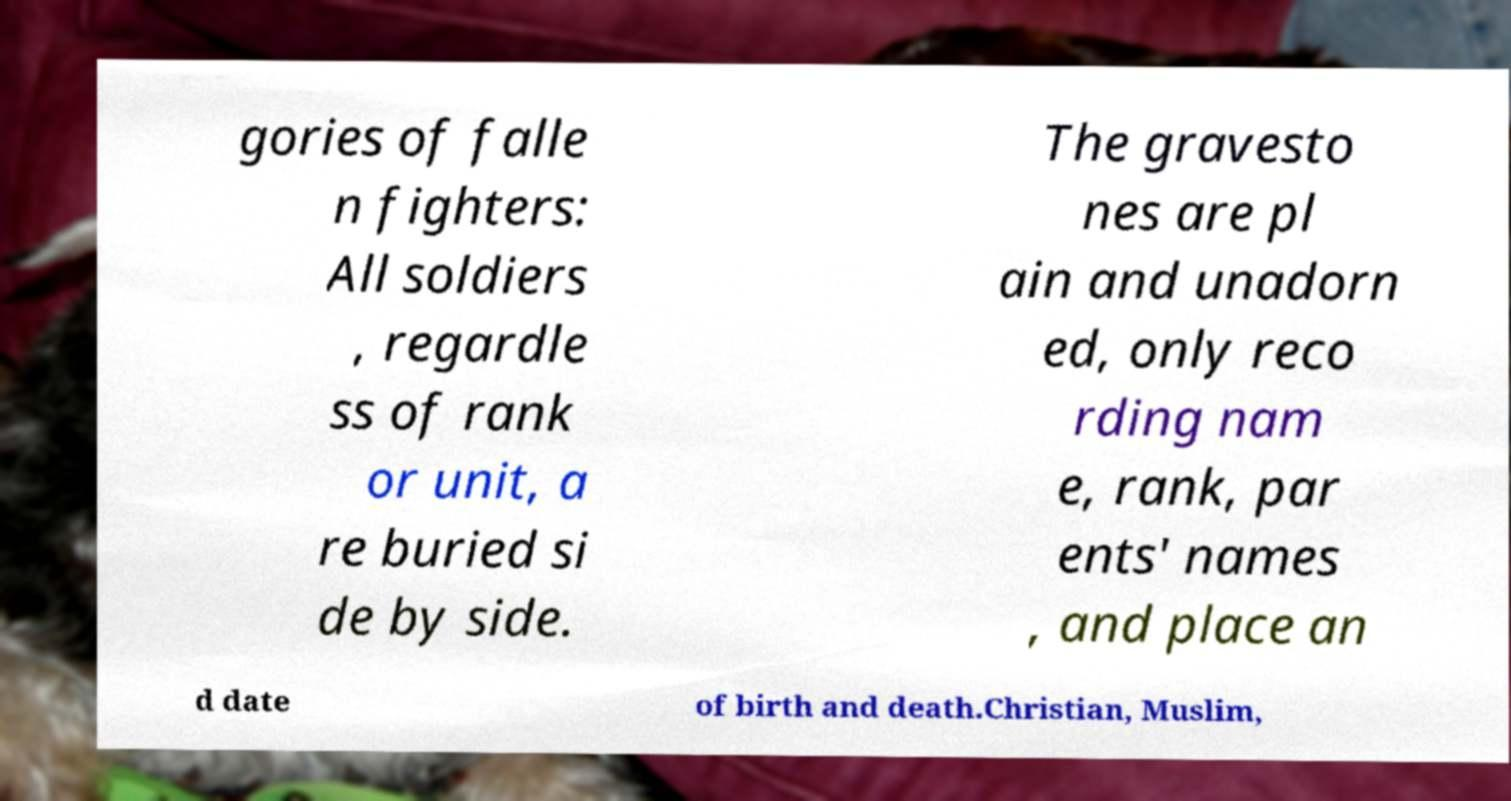Could you assist in decoding the text presented in this image and type it out clearly? gories of falle n fighters: All soldiers , regardle ss of rank or unit, a re buried si de by side. The gravesto nes are pl ain and unadorn ed, only reco rding nam e, rank, par ents' names , and place an d date of birth and death.Christian, Muslim, 